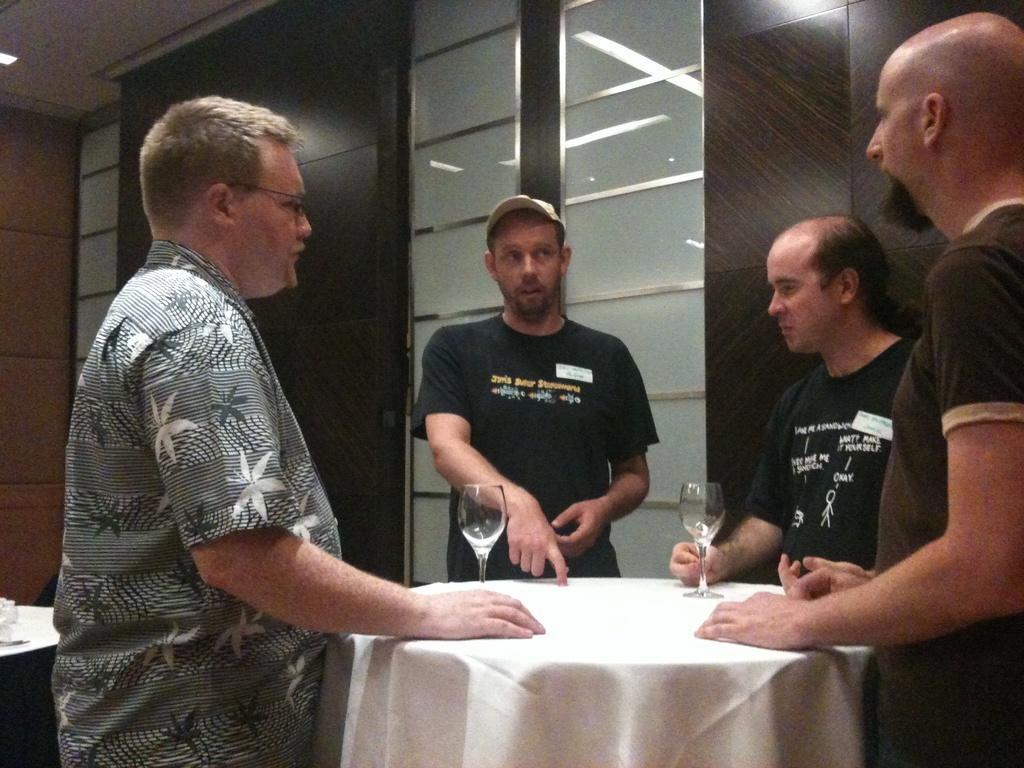Could you give a brief overview of what you see in this image? In this image I can see there are few men standing in front of a table. On the table I can see there are some cups on it. 